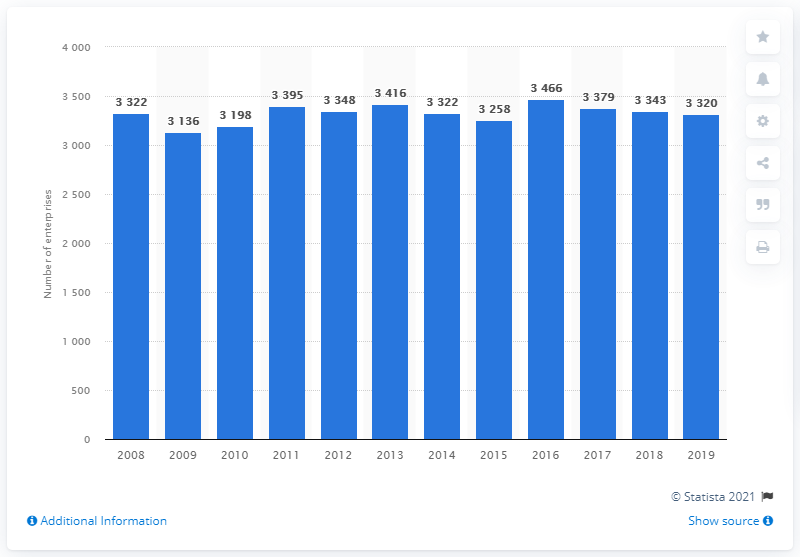Indicate a few pertinent items in this graphic. In the United Kingdom, specialized stores for the retail sale of bread, cakes, flour confectionary, and sugar confectionery were last available in 2008. 